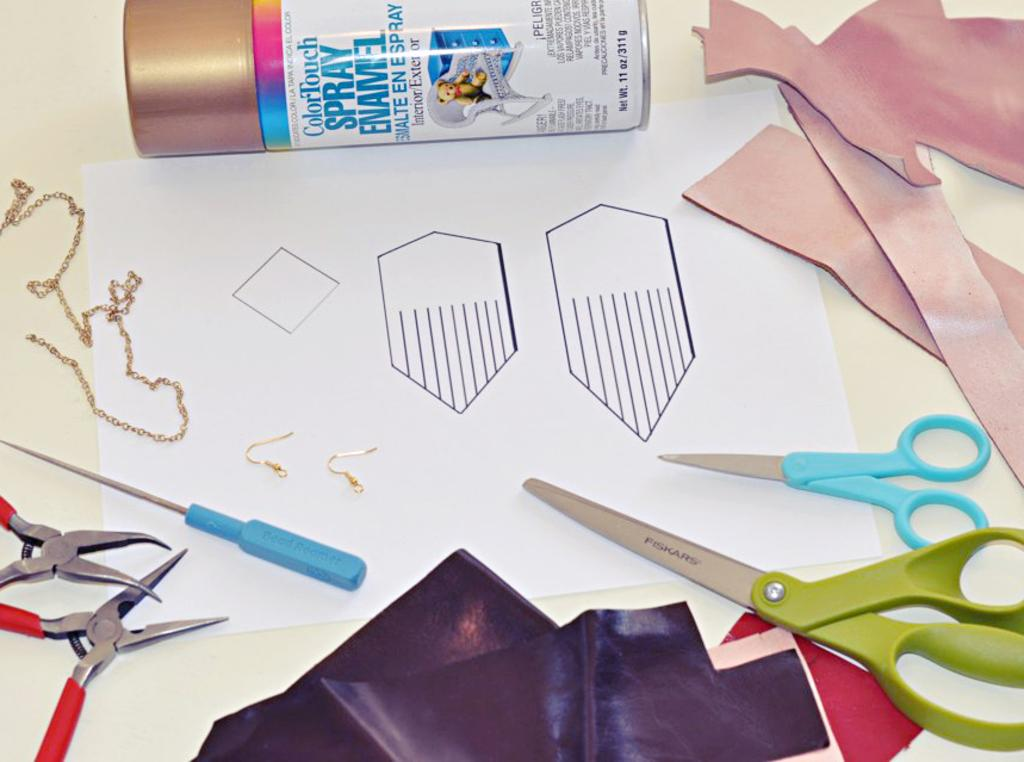What is the main piece of furniture in the image? There is a table in the image. What items can be seen on the table? There are papers, scissors, cutters, chains, a spray bottle, and an unspecified object on the table. What tools are present on the table that could be used for cutting? Scissors and cutters are present on the table. What type of container is visible on the table? There is a spray bottle on the table. Can you tell me how many zebras are drinking water from the spray bottle in the image? There are no zebras present in the image, and the spray bottle is not being used for drinking water. 